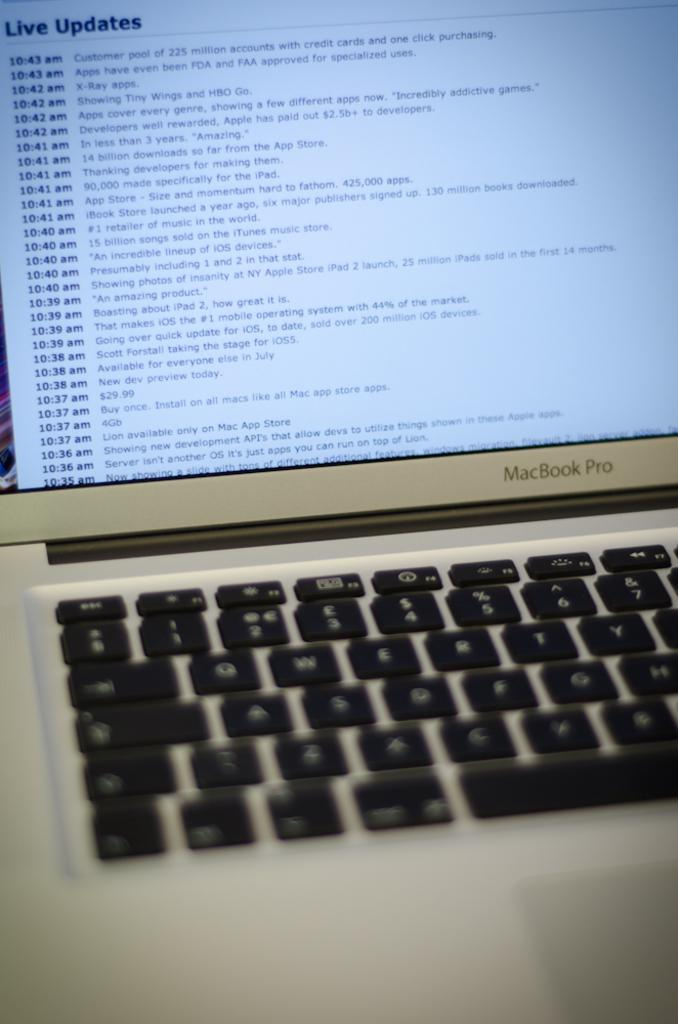<image>
Render a clear and concise summary of the photo. A laptop computer screen showing the live updates. 